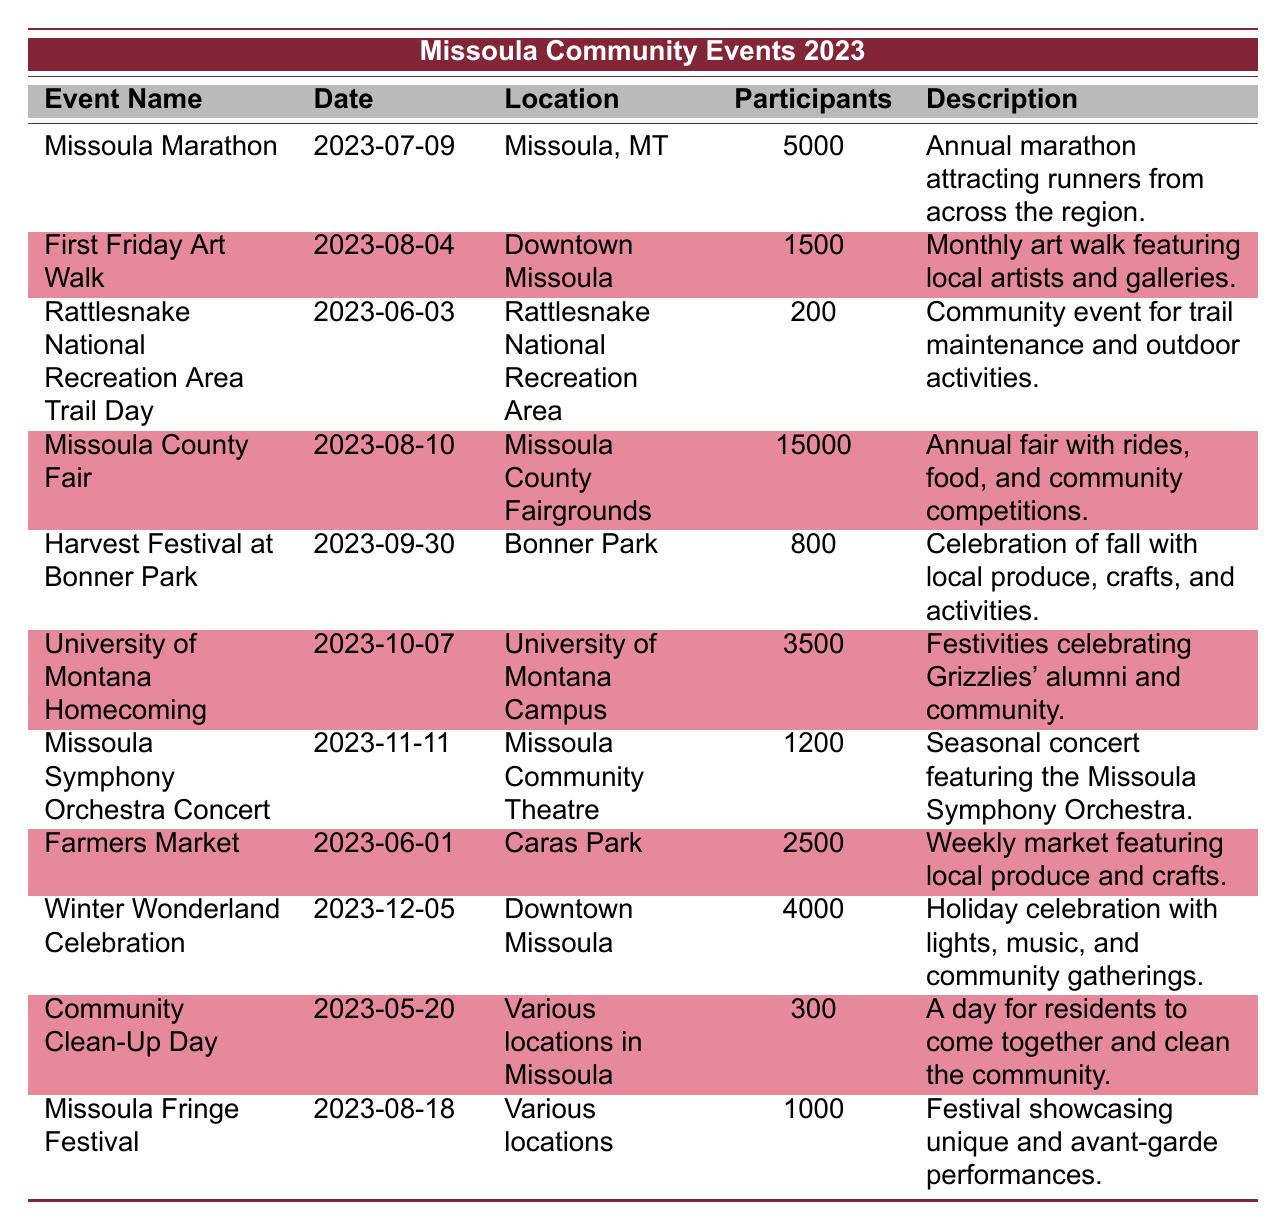What's the highest participation rate for an event in Missoula? The event with the highest participation rate listed is the Missoula County Fair with 15,000 participants.
Answer: 15,000 When did the Missoula Marathon take place? The Missoula Marathon took place on July 9, 2023.
Answer: July 9, 2023 How many events had a participation rate of over 3,000? The events that had a participation rate over 3,000 are the Missoula County Fair (15,000), Missoula Marathon (5,000), University of Montana Homecoming (3,500), and Winter Wonderland Celebration (4,000). This totals to 4 events.
Answer: 4 Which event had the lowest participation rate? The event with the lowest participation rate is the Rattlesnake National Recreation Area Trail Day with 200 participants.
Answer: 200 Is the First Friday Art Walk an annual event? No, the First Friday Art Walk is a monthly event, not an annual one.
Answer: No What is the average participation rate of all the events listed? To find the average, sum all participation rates: (5000 + 1500 + 200 + 15000 + 800 + 3500 + 1200 + 2500 + 4000 + 300 + 1000) = 28,000. There are 10 events, so the average participation rate is 28,000 / 10 = 2,800.
Answer: 2,800 Which event was held closest to the end of the year? The event held closest to the end of the year is the Winter Wonderland Celebration on December 5, 2023.
Answer: December 5, 2023 How many community events were held in June 2023? There were two community events held in June 2023: the Farmers Market on June 1 and the Rattlesnake National Recreation Area Trail Day on June 3.
Answer: 2 What are the total participants for all events held in August? The events held in August and their participation rates are: First Friday Art Walk (1,500), Missoula County Fair (15,000), and Missoula Fringe Festival (1,000). Total participants = 1,500 + 15,000 + 1,000 = 17,500.
Answer: 17,500 Was the Harvest Festival at Bonner Park more popular than the University of Montana Homecoming? No, the Harvest Festival at Bonner Park had 800 participants, while the University of Montana Homecoming had 3,500 participants, making the latter more popular.
Answer: No What percentage of the total participation rate came from the Missoula County Fair? The total participation rate is 28,000. The participation from the Missoula County Fair is 15,000. The percentage is (15,000 / 28,000) * 100 = 53.57%.
Answer: 53.57% 